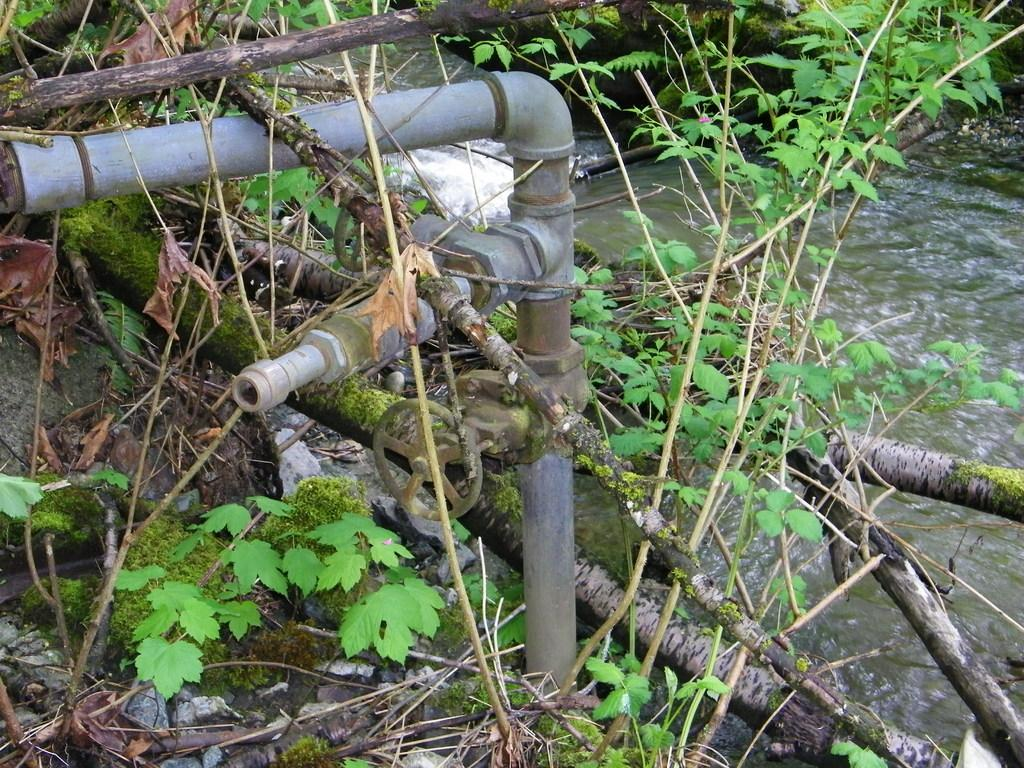What type of living organisms can be seen in the image? Plants can be seen in the image. What objects are present in the image that might be used for support or construction? Sticks and pipes are present in the image. What natural element is visible in the image? Water is visible in the image. What type of structure or mechanism is present in the image? There is a wheel in the image. What type of material is present in the image that might be used for construction or decoration? Stones are present in the image. What type of plant debris can be seen on the ground in the image? Leaves are on the ground in the image. Can you tell me what time it is according to the clock in the image? There is no clock present in the image. How many trees are visible in the image? There are no trees visible in the image. 